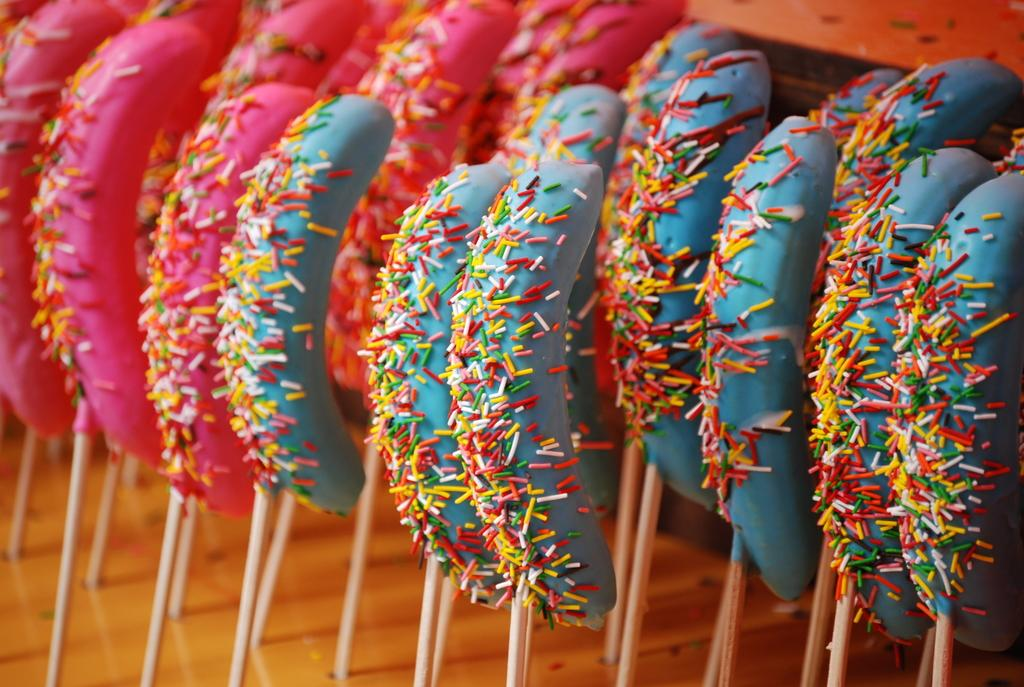What is the main subject of the image? The main subject of the image is food. How is the food being served or eaten? The food is served with sticks. What division or class of students can be seen in the image? There is no reference to students or any divisions or classes in the image; it features food served with sticks. 